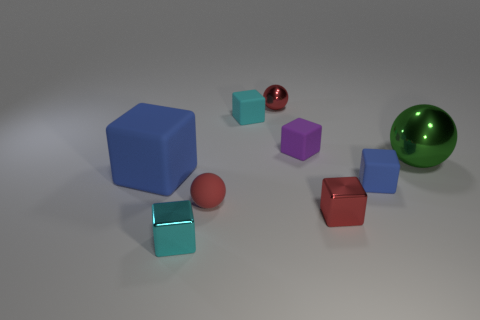Subtract 1 blocks. How many blocks are left? 5 Subtract all cyan cubes. How many cubes are left? 4 Subtract all small shiny blocks. How many blocks are left? 4 Subtract all blue balls. Subtract all gray cubes. How many balls are left? 3 Subtract all spheres. How many objects are left? 6 Add 3 tiny cyan cylinders. How many tiny cyan cylinders exist? 3 Subtract 0 gray blocks. How many objects are left? 9 Subtract all tiny red metallic objects. Subtract all large metallic cylinders. How many objects are left? 7 Add 4 tiny red balls. How many tiny red balls are left? 6 